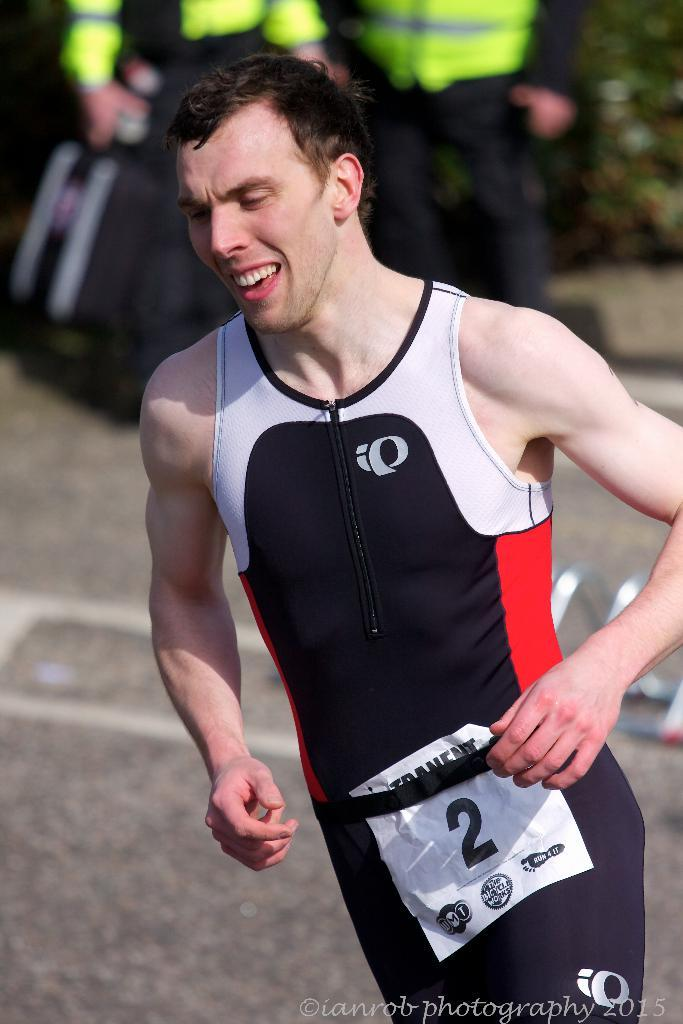<image>
Give a short and clear explanation of the subsequent image. Athlete number 2 wears a black body suit with red and white accents. 